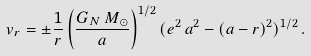Convert formula to latex. <formula><loc_0><loc_0><loc_500><loc_500>v _ { r } = \pm \frac { 1 } { r } \left ( \frac { G _ { N } \, M _ { \odot } } { a } \right ) ^ { 1 / 2 } ( e ^ { 2 } \, a ^ { 2 } - ( a - r ) ^ { 2 } ) ^ { 1 / 2 } \, .</formula> 